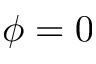Convert formula to latex. <formula><loc_0><loc_0><loc_500><loc_500>\phi = 0</formula> 